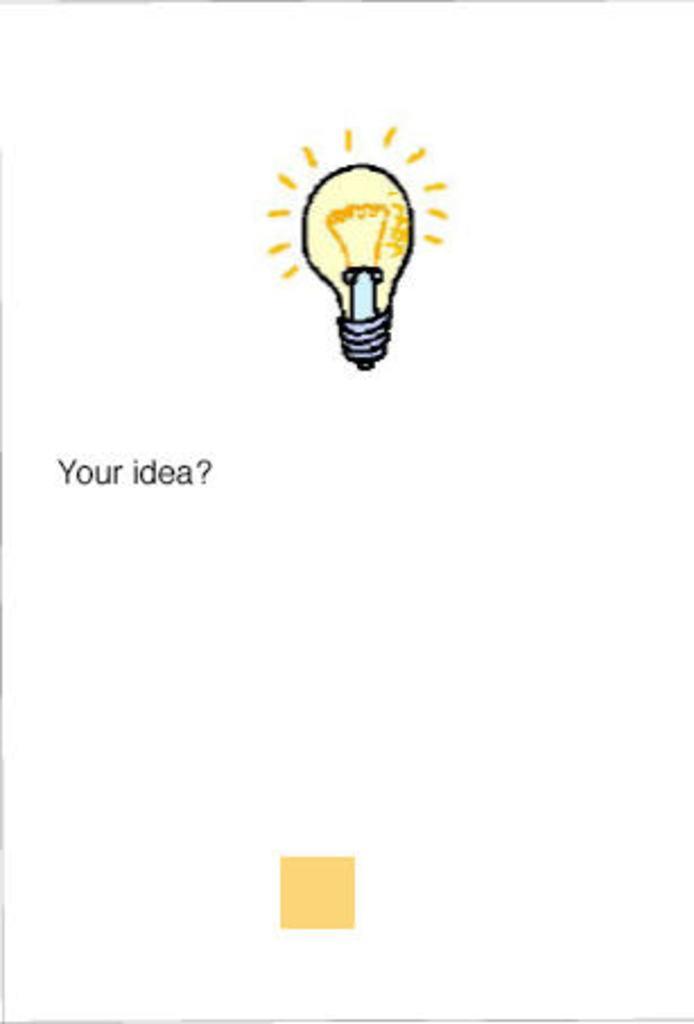How would you summarize this image in a sentence or two? In this image I can see picture of a bulb lighting, on the left side of the image I can see some text. At the bottom of the image I can see a square. 